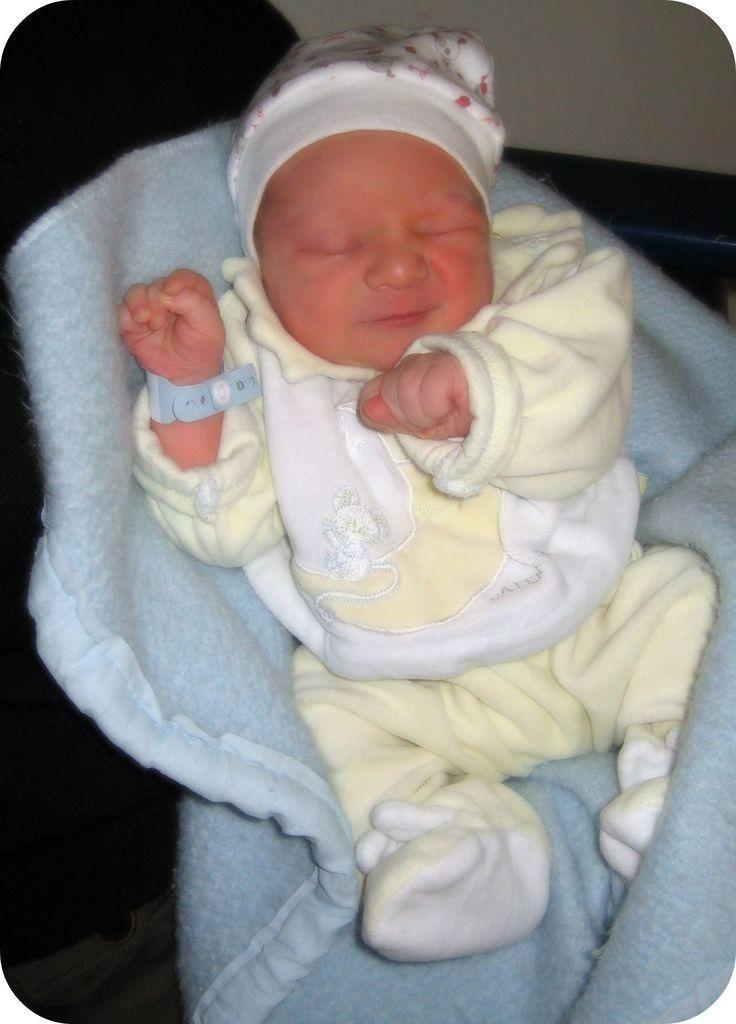In one or two sentences, can you explain what this image depicts? In this image a baby is on a cloth. Baby is wearing yellow dress. He is wearing a cap. Behind him there is a wall. 